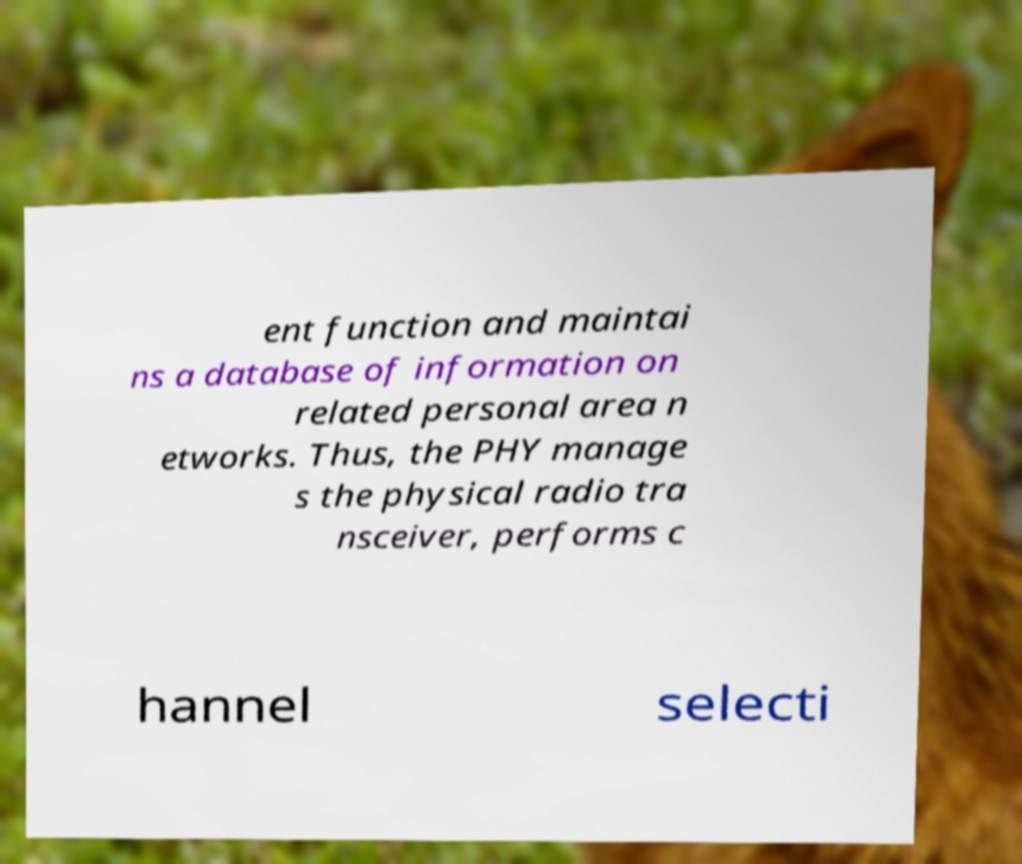I need the written content from this picture converted into text. Can you do that? ent function and maintai ns a database of information on related personal area n etworks. Thus, the PHY manage s the physical radio tra nsceiver, performs c hannel selecti 